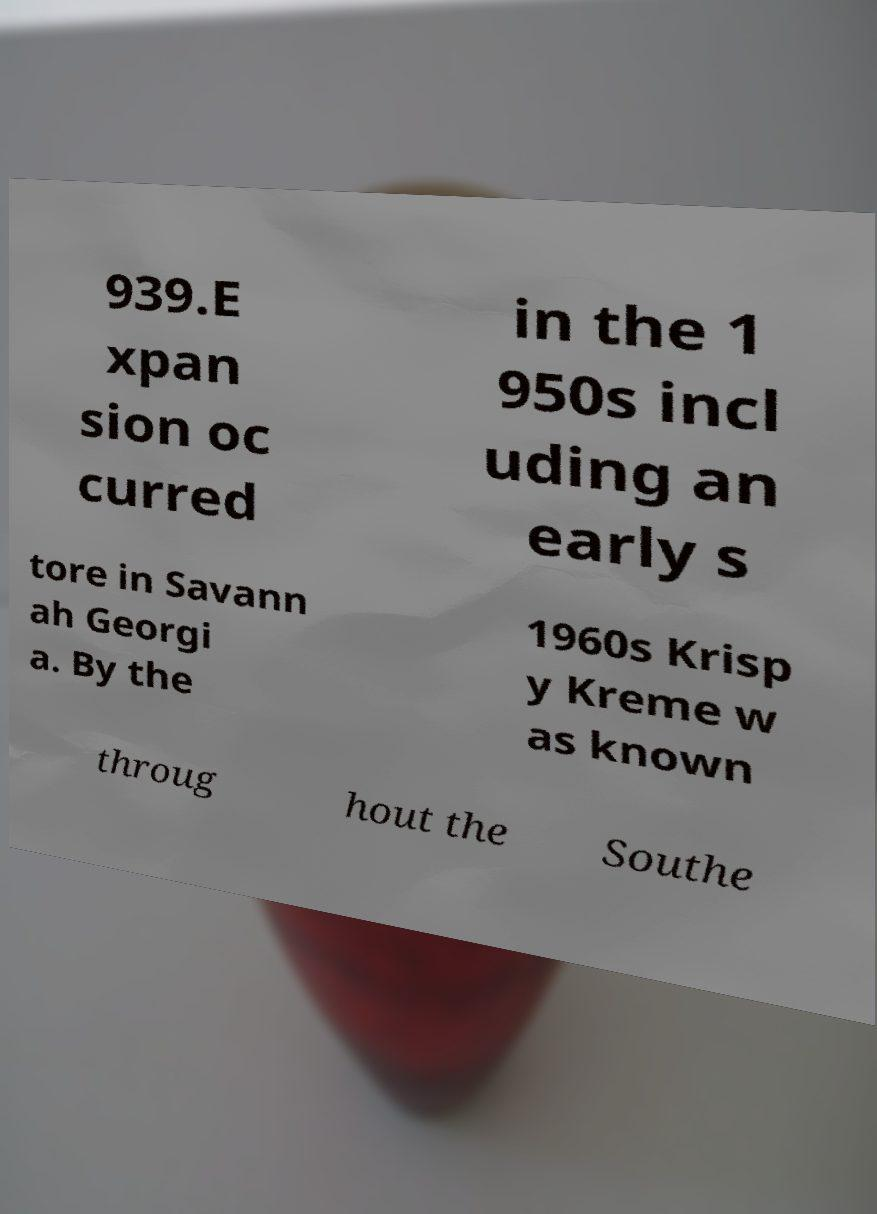I need the written content from this picture converted into text. Can you do that? 939.E xpan sion oc curred in the 1 950s incl uding an early s tore in Savann ah Georgi a. By the 1960s Krisp y Kreme w as known throug hout the Southe 